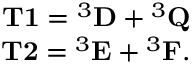<formula> <loc_0><loc_0><loc_500><loc_500>\begin{array} { r } { T 1 ^ { 3 } D ^ { 3 } Q } \\ { T 2 ^ { 3 } E ^ { 3 } F . } \end{array}</formula> 